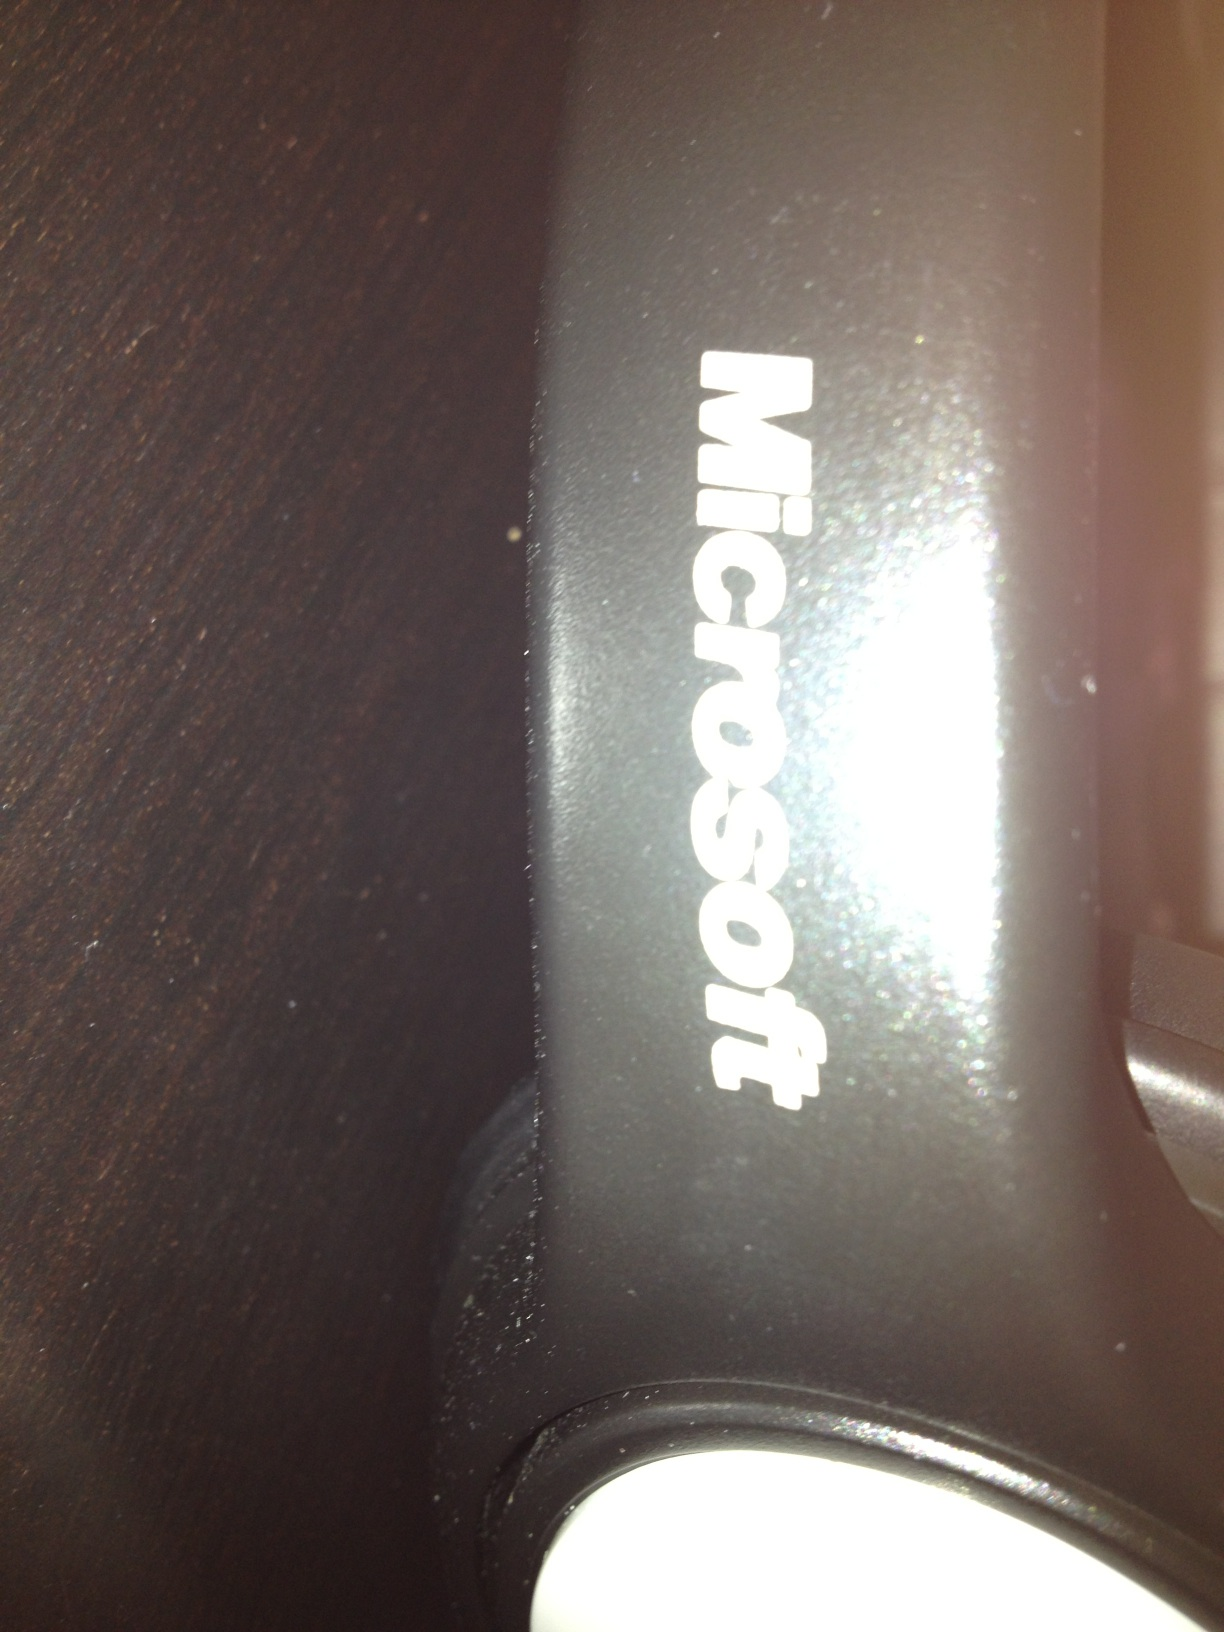Does this just say Microsoft or does it also give the product number? The image displays the brand name 'Microsoft' on a surface, but there is no visible product number included in the view. 